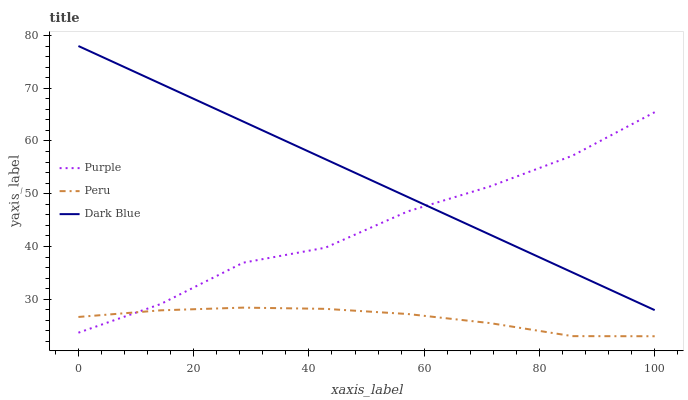Does Dark Blue have the minimum area under the curve?
Answer yes or no. No. Does Peru have the maximum area under the curve?
Answer yes or no. No. Is Peru the smoothest?
Answer yes or no. No. Is Peru the roughest?
Answer yes or no. No. Does Dark Blue have the lowest value?
Answer yes or no. No. Does Peru have the highest value?
Answer yes or no. No. Is Peru less than Dark Blue?
Answer yes or no. Yes. Is Dark Blue greater than Peru?
Answer yes or no. Yes. Does Peru intersect Dark Blue?
Answer yes or no. No. 